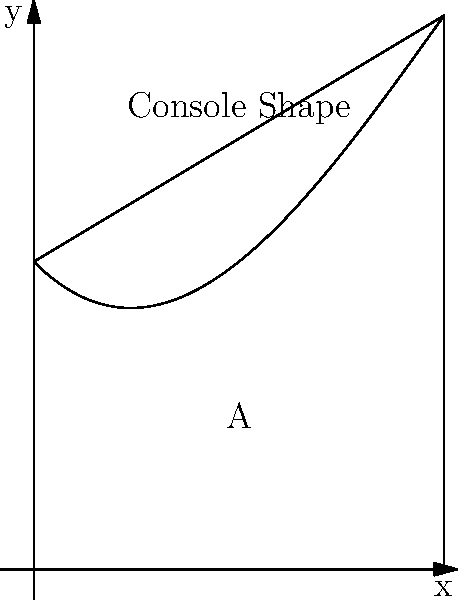A popular gaming console's silhouette can be modeled by the polynomial function $f(x) = -0.05x^3 + 0.6x^2 - x + 3$ from $x = 0$ to $x = 4$. Calculate the area A of the region bounded by the curve and the x-axis, which represents the console's unique shape. Round your answer to two decimal places. To find the area under the curve, we need to integrate the function from 0 to 4:

1) The area A is given by the definite integral:
   $$A = \int_{0}^{4} (-0.05x^3 + 0.6x^2 - x + 3) dx$$

2) Integrate each term:
   $$A = [-0.05\frac{x^4}{4} + 0.6\frac{x^3}{3} - \frac{x^2}{2} + 3x]_{0}^{4}$$

3) Evaluate at the upper and lower bounds:
   $$A = [-0.05\frac{4^4}{4} + 0.6\frac{4^3}{3} - \frac{4^2}{2} + 3(4)] - [-0.05\frac{0^4}{4} + 0.6\frac{0^3}{3} - \frac{0^2}{2} + 3(0)]$$

4) Simplify:
   $$A = [-3.2 + 12.8 - 8 + 12] - [0]$$
   $$A = 13.6 - 0 = 13.6$$

5) Round to two decimal places:
   $$A \approx 13.60$$

Thus, the area representing the console's shape is approximately 13.60 square units.
Answer: 13.60 square units 